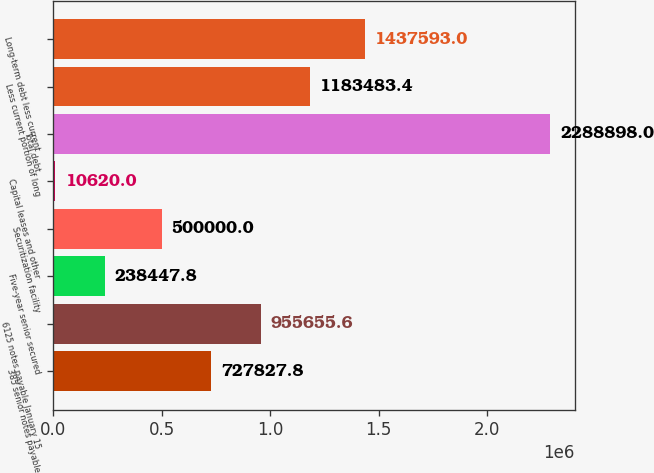Convert chart. <chart><loc_0><loc_0><loc_500><loc_500><bar_chart><fcel>385 senior notes payable<fcel>6125 notes payable January 15<fcel>Five-year senior secured<fcel>Securitization facility<fcel>Capital leases and other<fcel>Total debt<fcel>Less current portion of long<fcel>Long-term debt less current<nl><fcel>727828<fcel>955656<fcel>238448<fcel>500000<fcel>10620<fcel>2.2889e+06<fcel>1.18348e+06<fcel>1.43759e+06<nl></chart> 